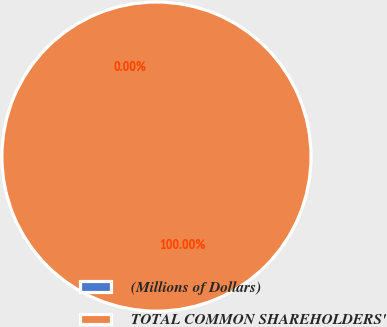Convert chart. <chart><loc_0><loc_0><loc_500><loc_500><pie_chart><fcel>(Millions of Dollars)<fcel>TOTAL COMMON SHAREHOLDERS'<nl><fcel>0.0%<fcel>100.0%<nl></chart> 